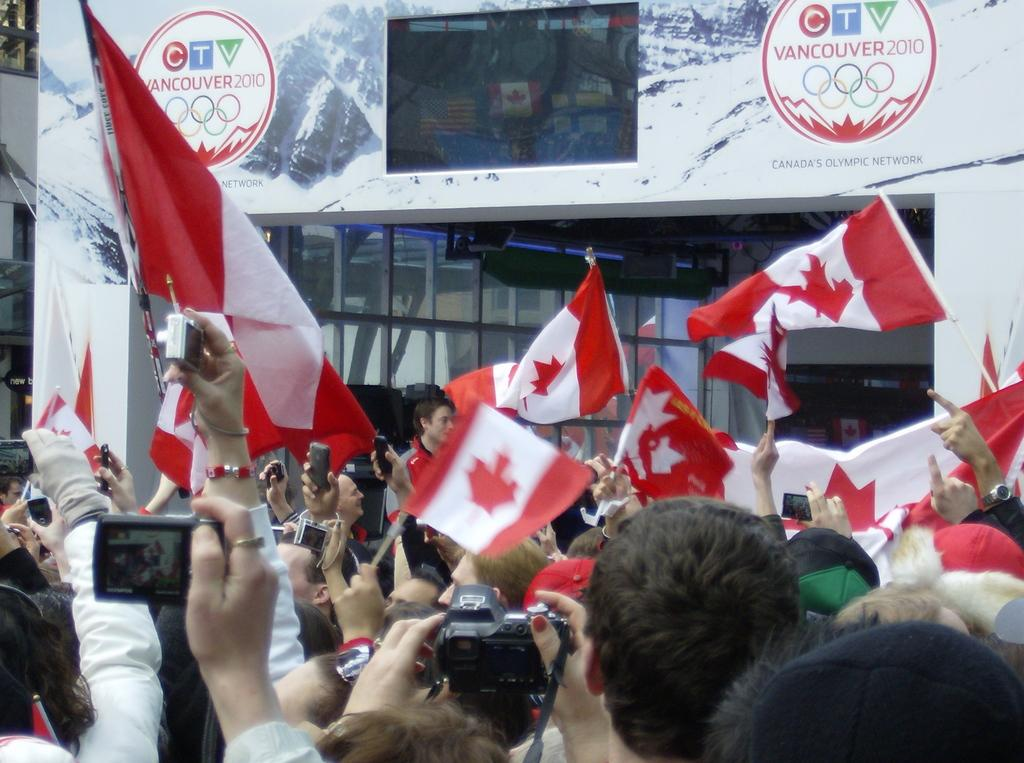What is the main subject of the image? The main subject of the image is a crowd of people. What are the people holding in the image? The people are holding cameras and flags in the image. What can be seen in the background of the image? There is a building in the background of the image. Can you describe any other objects in the image? There is a glass visible in the image. Who is the creator of the beetle seen in the image? There is no beetle present in the image, so it is not possible to determine who its creator might be. 